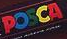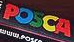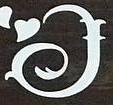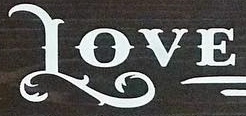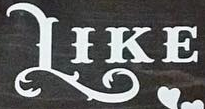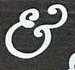What words are shown in these images in order, separated by a semicolon? POSCA; POSCA; I; LOVE; LIKE; & 